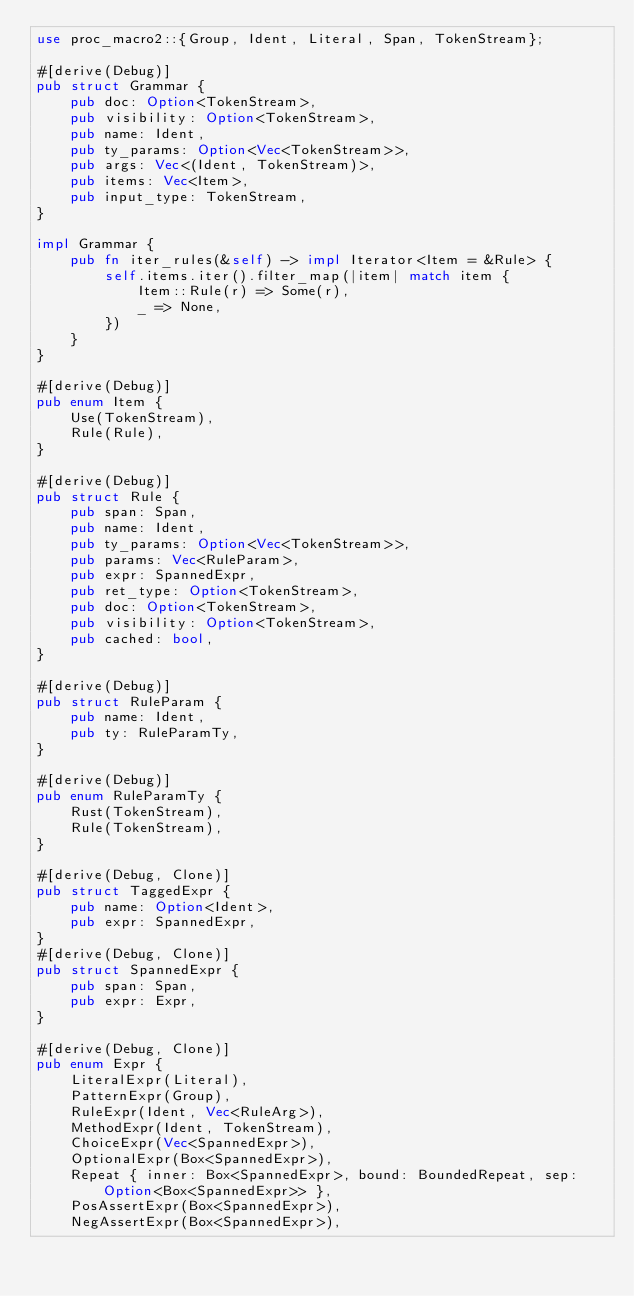<code> <loc_0><loc_0><loc_500><loc_500><_Rust_>use proc_macro2::{Group, Ident, Literal, Span, TokenStream};

#[derive(Debug)]
pub struct Grammar {
    pub doc: Option<TokenStream>,
    pub visibility: Option<TokenStream>,
    pub name: Ident,
    pub ty_params: Option<Vec<TokenStream>>,
    pub args: Vec<(Ident, TokenStream)>,
    pub items: Vec<Item>,
    pub input_type: TokenStream,
}

impl Grammar {
    pub fn iter_rules(&self) -> impl Iterator<Item = &Rule> {
        self.items.iter().filter_map(|item| match item {
            Item::Rule(r) => Some(r),
            _ => None,
        })
    }
}

#[derive(Debug)]
pub enum Item {
    Use(TokenStream),
    Rule(Rule),
}

#[derive(Debug)]
pub struct Rule {
    pub span: Span,
    pub name: Ident,
    pub ty_params: Option<Vec<TokenStream>>,
    pub params: Vec<RuleParam>,
    pub expr: SpannedExpr,
    pub ret_type: Option<TokenStream>,
    pub doc: Option<TokenStream>,
    pub visibility: Option<TokenStream>,
    pub cached: bool,
}

#[derive(Debug)]
pub struct RuleParam {
    pub name: Ident,
    pub ty: RuleParamTy,
}

#[derive(Debug)]
pub enum RuleParamTy {
    Rust(TokenStream),
    Rule(TokenStream),
}

#[derive(Debug, Clone)]
pub struct TaggedExpr {
    pub name: Option<Ident>,
    pub expr: SpannedExpr,
}
#[derive(Debug, Clone)]
pub struct SpannedExpr {
    pub span: Span,
    pub expr: Expr,
}

#[derive(Debug, Clone)]
pub enum Expr {
    LiteralExpr(Literal),
    PatternExpr(Group),
    RuleExpr(Ident, Vec<RuleArg>),
    MethodExpr(Ident, TokenStream),
    ChoiceExpr(Vec<SpannedExpr>),
    OptionalExpr(Box<SpannedExpr>),
    Repeat { inner: Box<SpannedExpr>, bound: BoundedRepeat, sep: Option<Box<SpannedExpr>> },
    PosAssertExpr(Box<SpannedExpr>),
    NegAssertExpr(Box<SpannedExpr>),</code> 